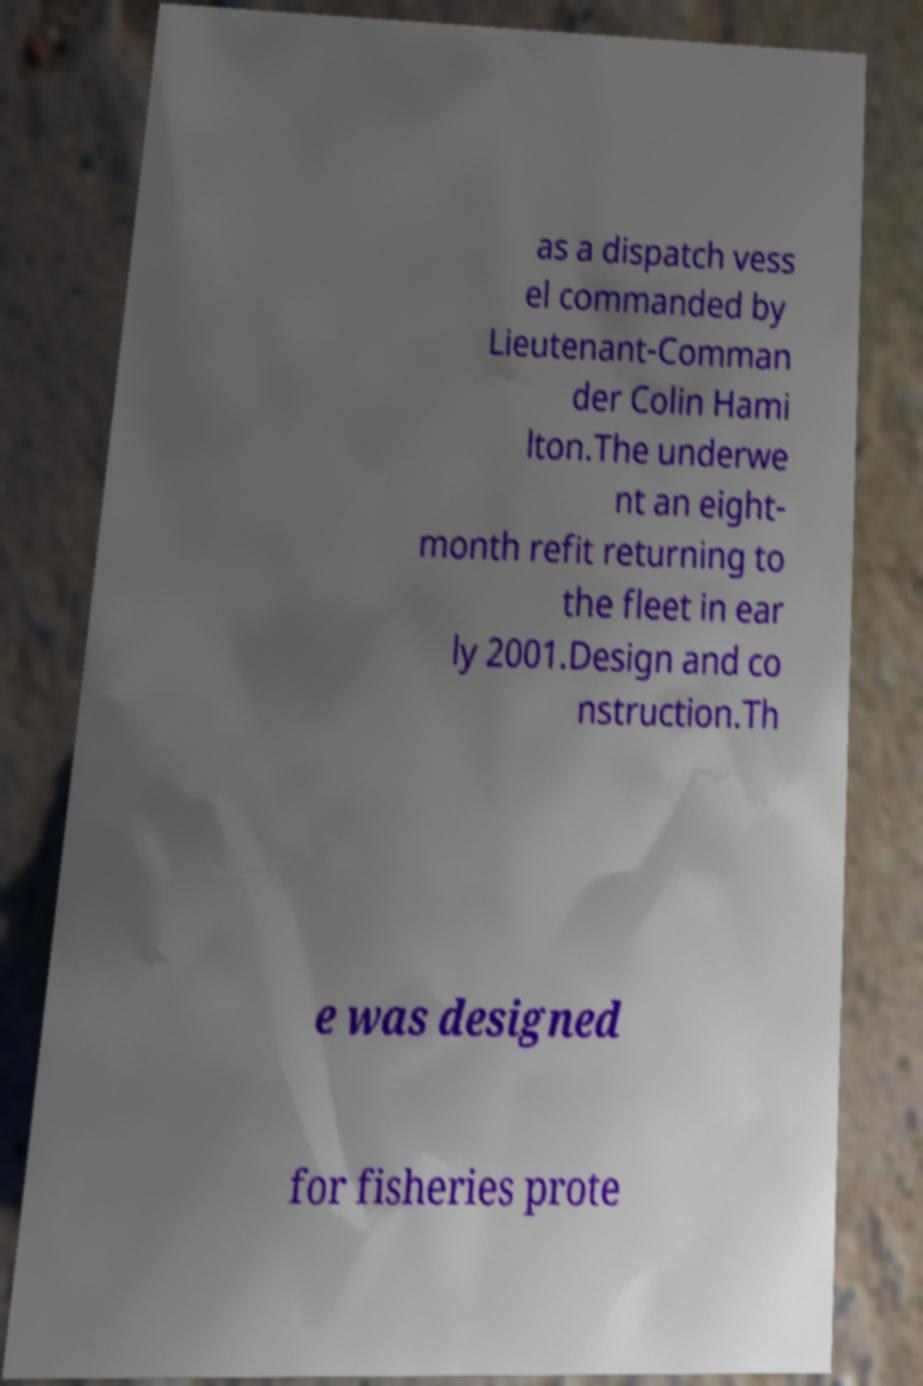Can you accurately transcribe the text from the provided image for me? as a dispatch vess el commanded by Lieutenant-Comman der Colin Hami lton.The underwe nt an eight- month refit returning to the fleet in ear ly 2001.Design and co nstruction.Th e was designed for fisheries prote 